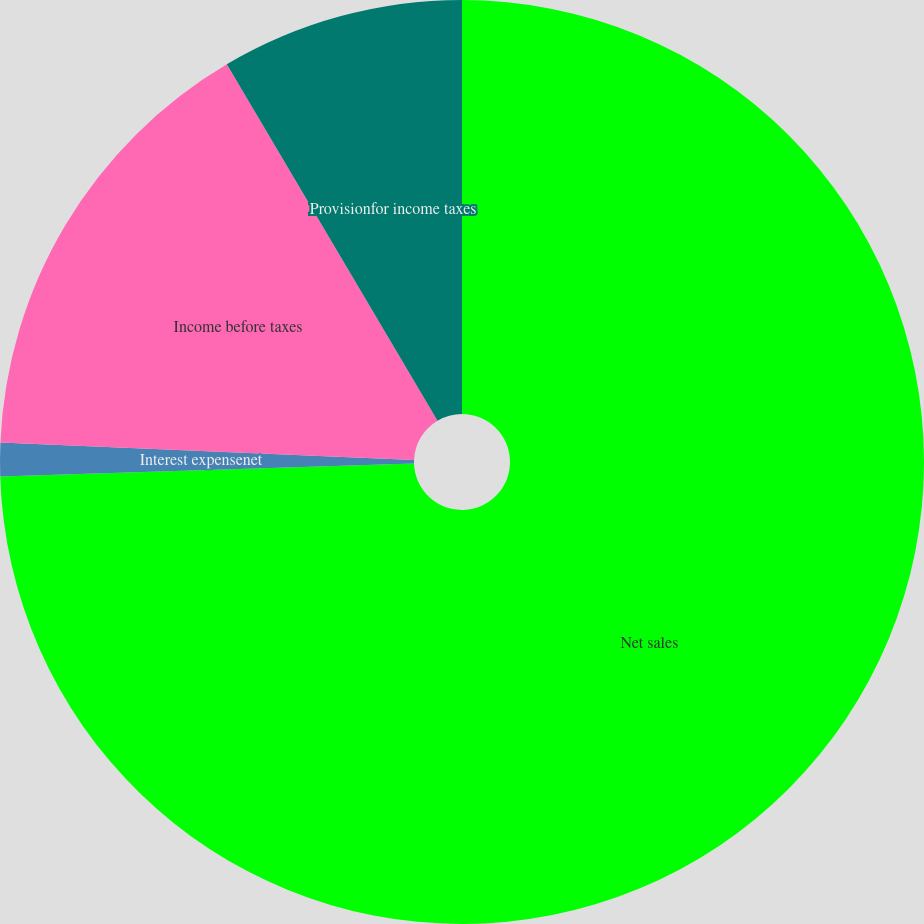Convert chart. <chart><loc_0><loc_0><loc_500><loc_500><pie_chart><fcel>Net sales<fcel>Interest expensenet<fcel>Income before taxes<fcel>Provisionfor income taxes<nl><fcel>74.5%<fcel>1.17%<fcel>15.83%<fcel>8.5%<nl></chart> 